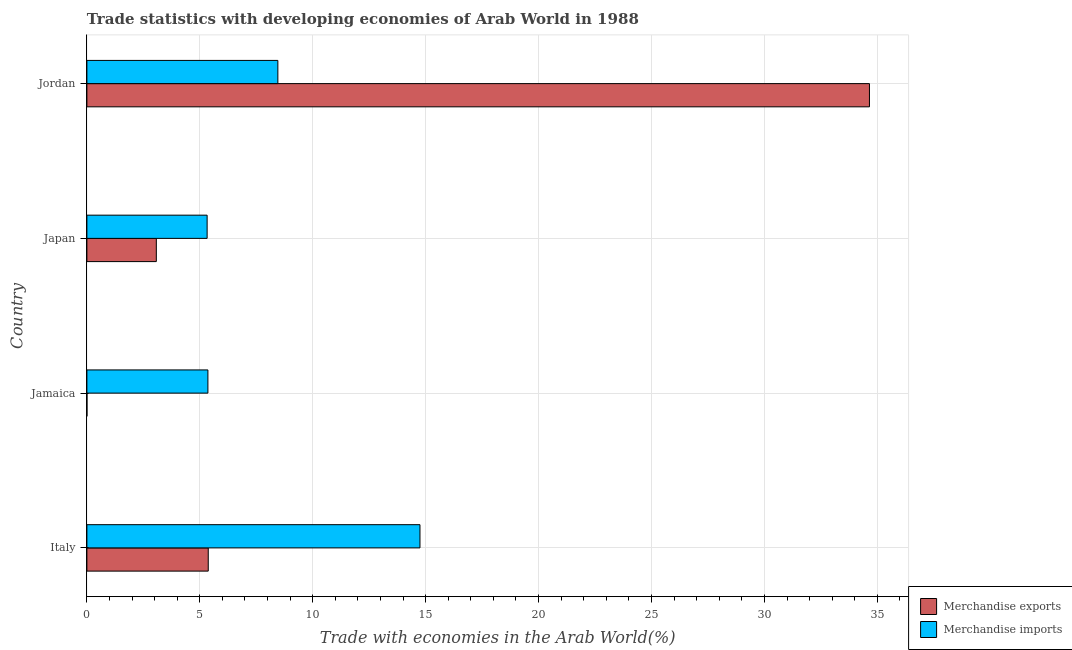How many different coloured bars are there?
Your answer should be very brief. 2. Are the number of bars on each tick of the Y-axis equal?
Provide a succinct answer. Yes. What is the label of the 3rd group of bars from the top?
Provide a short and direct response. Jamaica. In how many cases, is the number of bars for a given country not equal to the number of legend labels?
Offer a terse response. 0. What is the merchandise imports in Japan?
Your response must be concise. 5.32. Across all countries, what is the maximum merchandise imports?
Offer a very short reply. 14.75. Across all countries, what is the minimum merchandise exports?
Your answer should be compact. 0. In which country was the merchandise imports maximum?
Provide a succinct answer. Italy. What is the total merchandise exports in the graph?
Your response must be concise. 43.1. What is the difference between the merchandise exports in Jamaica and that in Jordan?
Your answer should be compact. -34.65. What is the difference between the merchandise exports in Japan and the merchandise imports in Jordan?
Offer a very short reply. -5.38. What is the average merchandise imports per country?
Ensure brevity in your answer.  8.47. What is the difference between the merchandise imports and merchandise exports in Italy?
Give a very brief answer. 9.38. In how many countries, is the merchandise imports greater than 11 %?
Provide a short and direct response. 1. What is the ratio of the merchandise imports in Japan to that in Jordan?
Keep it short and to the point. 0.63. Is the difference between the merchandise imports in Italy and Jamaica greater than the difference between the merchandise exports in Italy and Jamaica?
Make the answer very short. Yes. What is the difference between the highest and the second highest merchandise imports?
Give a very brief answer. 6.29. What is the difference between the highest and the lowest merchandise exports?
Ensure brevity in your answer.  34.65. In how many countries, is the merchandise imports greater than the average merchandise imports taken over all countries?
Provide a succinct answer. 1. Is the sum of the merchandise imports in Jamaica and Japan greater than the maximum merchandise exports across all countries?
Your answer should be compact. No. What does the 1st bar from the top in Jamaica represents?
Keep it short and to the point. Merchandise imports. How many bars are there?
Give a very brief answer. 8. How many countries are there in the graph?
Provide a succinct answer. 4. What is the difference between two consecutive major ticks on the X-axis?
Your answer should be compact. 5. Are the values on the major ticks of X-axis written in scientific E-notation?
Offer a very short reply. No. Does the graph contain grids?
Keep it short and to the point. Yes. How many legend labels are there?
Provide a succinct answer. 2. How are the legend labels stacked?
Your answer should be very brief. Vertical. What is the title of the graph?
Provide a short and direct response. Trade statistics with developing economies of Arab World in 1988. Does "Crop" appear as one of the legend labels in the graph?
Your answer should be very brief. No. What is the label or title of the X-axis?
Keep it short and to the point. Trade with economies in the Arab World(%). What is the label or title of the Y-axis?
Make the answer very short. Country. What is the Trade with economies in the Arab World(%) of Merchandise exports in Italy?
Your response must be concise. 5.37. What is the Trade with economies in the Arab World(%) of Merchandise imports in Italy?
Give a very brief answer. 14.75. What is the Trade with economies in the Arab World(%) of Merchandise exports in Jamaica?
Make the answer very short. 0. What is the Trade with economies in the Arab World(%) of Merchandise imports in Jamaica?
Give a very brief answer. 5.36. What is the Trade with economies in the Arab World(%) of Merchandise exports in Japan?
Provide a short and direct response. 3.07. What is the Trade with economies in the Arab World(%) of Merchandise imports in Japan?
Ensure brevity in your answer.  5.32. What is the Trade with economies in the Arab World(%) in Merchandise exports in Jordan?
Keep it short and to the point. 34.65. What is the Trade with economies in the Arab World(%) in Merchandise imports in Jordan?
Ensure brevity in your answer.  8.46. Across all countries, what is the maximum Trade with economies in the Arab World(%) of Merchandise exports?
Provide a short and direct response. 34.65. Across all countries, what is the maximum Trade with economies in the Arab World(%) in Merchandise imports?
Make the answer very short. 14.75. Across all countries, what is the minimum Trade with economies in the Arab World(%) in Merchandise exports?
Your answer should be very brief. 0. Across all countries, what is the minimum Trade with economies in the Arab World(%) in Merchandise imports?
Ensure brevity in your answer.  5.32. What is the total Trade with economies in the Arab World(%) of Merchandise exports in the graph?
Give a very brief answer. 43.1. What is the total Trade with economies in the Arab World(%) in Merchandise imports in the graph?
Provide a succinct answer. 33.89. What is the difference between the Trade with economies in the Arab World(%) of Merchandise exports in Italy and that in Jamaica?
Provide a short and direct response. 5.37. What is the difference between the Trade with economies in the Arab World(%) in Merchandise imports in Italy and that in Jamaica?
Provide a short and direct response. 9.39. What is the difference between the Trade with economies in the Arab World(%) of Merchandise exports in Italy and that in Japan?
Ensure brevity in your answer.  2.3. What is the difference between the Trade with economies in the Arab World(%) of Merchandise imports in Italy and that in Japan?
Provide a short and direct response. 9.42. What is the difference between the Trade with economies in the Arab World(%) of Merchandise exports in Italy and that in Jordan?
Make the answer very short. -29.28. What is the difference between the Trade with economies in the Arab World(%) in Merchandise imports in Italy and that in Jordan?
Make the answer very short. 6.29. What is the difference between the Trade with economies in the Arab World(%) of Merchandise exports in Jamaica and that in Japan?
Ensure brevity in your answer.  -3.07. What is the difference between the Trade with economies in the Arab World(%) of Merchandise imports in Jamaica and that in Japan?
Ensure brevity in your answer.  0.03. What is the difference between the Trade with economies in the Arab World(%) of Merchandise exports in Jamaica and that in Jordan?
Your answer should be compact. -34.65. What is the difference between the Trade with economies in the Arab World(%) in Merchandise imports in Jamaica and that in Jordan?
Offer a very short reply. -3.1. What is the difference between the Trade with economies in the Arab World(%) of Merchandise exports in Japan and that in Jordan?
Your response must be concise. -31.58. What is the difference between the Trade with economies in the Arab World(%) in Merchandise imports in Japan and that in Jordan?
Your answer should be compact. -3.13. What is the difference between the Trade with economies in the Arab World(%) of Merchandise exports in Italy and the Trade with economies in the Arab World(%) of Merchandise imports in Jamaica?
Give a very brief answer. 0.01. What is the difference between the Trade with economies in the Arab World(%) in Merchandise exports in Italy and the Trade with economies in the Arab World(%) in Merchandise imports in Japan?
Make the answer very short. 0.05. What is the difference between the Trade with economies in the Arab World(%) of Merchandise exports in Italy and the Trade with economies in the Arab World(%) of Merchandise imports in Jordan?
Make the answer very short. -3.08. What is the difference between the Trade with economies in the Arab World(%) in Merchandise exports in Jamaica and the Trade with economies in the Arab World(%) in Merchandise imports in Japan?
Keep it short and to the point. -5.32. What is the difference between the Trade with economies in the Arab World(%) of Merchandise exports in Jamaica and the Trade with economies in the Arab World(%) of Merchandise imports in Jordan?
Ensure brevity in your answer.  -8.45. What is the difference between the Trade with economies in the Arab World(%) of Merchandise exports in Japan and the Trade with economies in the Arab World(%) of Merchandise imports in Jordan?
Your response must be concise. -5.38. What is the average Trade with economies in the Arab World(%) of Merchandise exports per country?
Make the answer very short. 10.78. What is the average Trade with economies in the Arab World(%) of Merchandise imports per country?
Ensure brevity in your answer.  8.47. What is the difference between the Trade with economies in the Arab World(%) in Merchandise exports and Trade with economies in the Arab World(%) in Merchandise imports in Italy?
Offer a very short reply. -9.37. What is the difference between the Trade with economies in the Arab World(%) of Merchandise exports and Trade with economies in the Arab World(%) of Merchandise imports in Jamaica?
Offer a very short reply. -5.36. What is the difference between the Trade with economies in the Arab World(%) in Merchandise exports and Trade with economies in the Arab World(%) in Merchandise imports in Japan?
Make the answer very short. -2.25. What is the difference between the Trade with economies in the Arab World(%) of Merchandise exports and Trade with economies in the Arab World(%) of Merchandise imports in Jordan?
Make the answer very short. 26.2. What is the ratio of the Trade with economies in the Arab World(%) in Merchandise exports in Italy to that in Jamaica?
Make the answer very short. 2571.01. What is the ratio of the Trade with economies in the Arab World(%) of Merchandise imports in Italy to that in Jamaica?
Provide a succinct answer. 2.75. What is the ratio of the Trade with economies in the Arab World(%) in Merchandise exports in Italy to that in Japan?
Ensure brevity in your answer.  1.75. What is the ratio of the Trade with economies in the Arab World(%) in Merchandise imports in Italy to that in Japan?
Your response must be concise. 2.77. What is the ratio of the Trade with economies in the Arab World(%) of Merchandise exports in Italy to that in Jordan?
Give a very brief answer. 0.16. What is the ratio of the Trade with economies in the Arab World(%) in Merchandise imports in Italy to that in Jordan?
Make the answer very short. 1.74. What is the ratio of the Trade with economies in the Arab World(%) of Merchandise exports in Jamaica to that in Japan?
Your answer should be very brief. 0. What is the ratio of the Trade with economies in the Arab World(%) of Merchandise imports in Jamaica to that in Japan?
Ensure brevity in your answer.  1.01. What is the ratio of the Trade with economies in the Arab World(%) of Merchandise imports in Jamaica to that in Jordan?
Give a very brief answer. 0.63. What is the ratio of the Trade with economies in the Arab World(%) of Merchandise exports in Japan to that in Jordan?
Provide a succinct answer. 0.09. What is the ratio of the Trade with economies in the Arab World(%) of Merchandise imports in Japan to that in Jordan?
Your response must be concise. 0.63. What is the difference between the highest and the second highest Trade with economies in the Arab World(%) in Merchandise exports?
Your answer should be compact. 29.28. What is the difference between the highest and the second highest Trade with economies in the Arab World(%) of Merchandise imports?
Offer a very short reply. 6.29. What is the difference between the highest and the lowest Trade with economies in the Arab World(%) of Merchandise exports?
Ensure brevity in your answer.  34.65. What is the difference between the highest and the lowest Trade with economies in the Arab World(%) of Merchandise imports?
Provide a short and direct response. 9.42. 